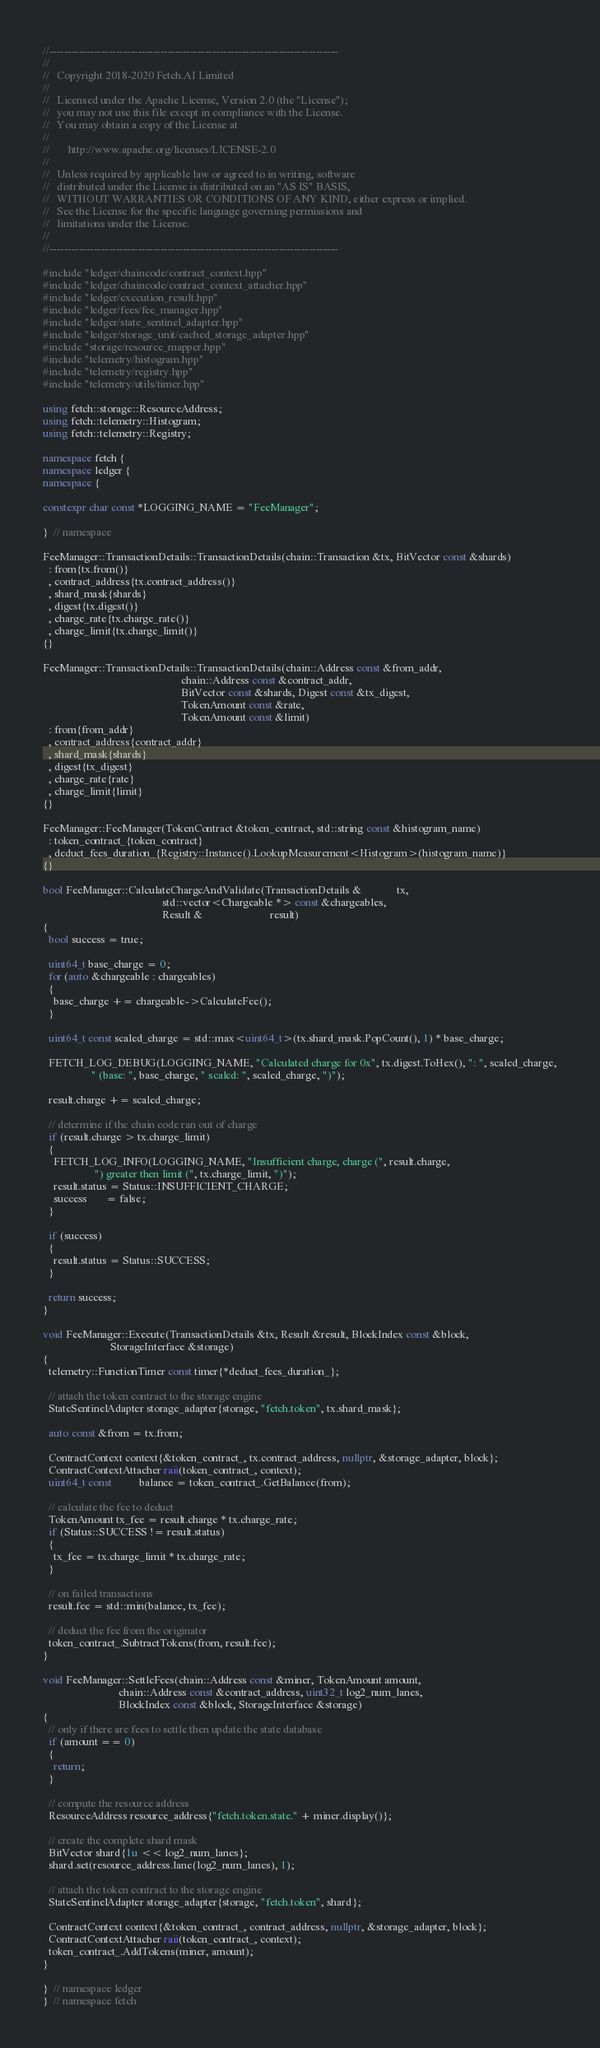Convert code to text. <code><loc_0><loc_0><loc_500><loc_500><_C++_>//------------------------------------------------------------------------------
//
//   Copyright 2018-2020 Fetch.AI Limited
//
//   Licensed under the Apache License, Version 2.0 (the "License");
//   you may not use this file except in compliance with the License.
//   You may obtain a copy of the License at
//
//       http://www.apache.org/licenses/LICENSE-2.0
//
//   Unless required by applicable law or agreed to in writing, software
//   distributed under the License is distributed on an "AS IS" BASIS,
//   WITHOUT WARRANTIES OR CONDITIONS OF ANY KIND, either express or implied.
//   See the License for the specific language governing permissions and
//   limitations under the License.
//
//------------------------------------------------------------------------------

#include "ledger/chaincode/contract_context.hpp"
#include "ledger/chaincode/contract_context_attacher.hpp"
#include "ledger/execution_result.hpp"
#include "ledger/fees/fee_manager.hpp"
#include "ledger/state_sentinel_adapter.hpp"
#include "ledger/storage_unit/cached_storage_adapter.hpp"
#include "storage/resource_mapper.hpp"
#include "telemetry/histogram.hpp"
#include "telemetry/registry.hpp"
#include "telemetry/utils/timer.hpp"

using fetch::storage::ResourceAddress;
using fetch::telemetry::Histogram;
using fetch::telemetry::Registry;

namespace fetch {
namespace ledger {
namespace {

constexpr char const *LOGGING_NAME = "FeeManager";

}  // namespace

FeeManager::TransactionDetails::TransactionDetails(chain::Transaction &tx, BitVector const &shards)
  : from{tx.from()}
  , contract_address{tx.contract_address()}
  , shard_mask{shards}
  , digest{tx.digest()}
  , charge_rate{tx.charge_rate()}
  , charge_limit{tx.charge_limit()}
{}

FeeManager::TransactionDetails::TransactionDetails(chain::Address const &from_addr,
                                                   chain::Address const &contract_addr,
                                                   BitVector const &shards, Digest const &tx_digest,
                                                   TokenAmount const &rate,
                                                   TokenAmount const &limit)
  : from{from_addr}
  , contract_address{contract_addr}
  , shard_mask{shards}
  , digest{tx_digest}
  , charge_rate{rate}
  , charge_limit{limit}
{}

FeeManager::FeeManager(TokenContract &token_contract, std::string const &histogram_name)
  : token_contract_{token_contract}
  , deduct_fees_duration_{Registry::Instance().LookupMeasurement<Histogram>(histogram_name)}
{}

bool FeeManager::CalculateChargeAndValidate(TransactionDetails &             tx,
                                            std::vector<Chargeable *> const &chargeables,
                                            Result &                         result)
{
  bool success = true;

  uint64_t base_charge = 0;
  for (auto &chargeable : chargeables)
  {
    base_charge += chargeable->CalculateFee();
  }

  uint64_t const scaled_charge = std::max<uint64_t>(tx.shard_mask.PopCount(), 1) * base_charge;

  FETCH_LOG_DEBUG(LOGGING_NAME, "Calculated charge for 0x", tx.digest.ToHex(), ": ", scaled_charge,
                  " (base: ", base_charge, " scaled: ", scaled_charge, ")");

  result.charge += scaled_charge;

  // determine if the chain code ran out of charge
  if (result.charge > tx.charge_limit)
  {
    FETCH_LOG_INFO(LOGGING_NAME, "Insufficient charge, charge (", result.charge,
                   ") greater then limit (", tx.charge_limit, ")");
    result.status = Status::INSUFFICIENT_CHARGE;
    success       = false;
  }

  if (success)
  {
    result.status = Status::SUCCESS;
  }

  return success;
}

void FeeManager::Execute(TransactionDetails &tx, Result &result, BlockIndex const &block,
                         StorageInterface &storage)
{
  telemetry::FunctionTimer const timer{*deduct_fees_duration_};

  // attach the token contract to the storage engine
  StateSentinelAdapter storage_adapter{storage, "fetch.token", tx.shard_mask};

  auto const &from = tx.from;

  ContractContext context{&token_contract_, tx.contract_address, nullptr, &storage_adapter, block};
  ContractContextAttacher raii(token_contract_, context);
  uint64_t const          balance = token_contract_.GetBalance(from);

  // calculate the fee to deduct
  TokenAmount tx_fee = result.charge * tx.charge_rate;
  if (Status::SUCCESS != result.status)
  {
    tx_fee = tx.charge_limit * tx.charge_rate;
  }

  // on failed transactions
  result.fee = std::min(balance, tx_fee);

  // deduct the fee from the originator
  token_contract_.SubtractTokens(from, result.fee);
}

void FeeManager::SettleFees(chain::Address const &miner, TokenAmount amount,
                            chain::Address const &contract_address, uint32_t log2_num_lanes,
                            BlockIndex const &block, StorageInterface &storage)
{
  // only if there are fees to settle then update the state database
  if (amount == 0)
  {
    return;
  }

  // compute the resource address
  ResourceAddress resource_address{"fetch.token.state." + miner.display()};

  // create the complete shard mask
  BitVector shard{1u << log2_num_lanes};
  shard.set(resource_address.lane(log2_num_lanes), 1);

  // attach the token contract to the storage engine
  StateSentinelAdapter storage_adapter{storage, "fetch.token", shard};

  ContractContext context{&token_contract_, contract_address, nullptr, &storage_adapter, block};
  ContractContextAttacher raii(token_contract_, context);
  token_contract_.AddTokens(miner, amount);
}

}  // namespace ledger
}  // namespace fetch
</code> 